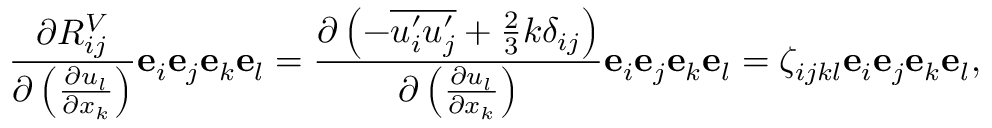<formula> <loc_0><loc_0><loc_500><loc_500>\frac { \partial R _ { i j } ^ { V } } { \partial \left ( \frac { \partial u _ { l } } { \partial x _ { k } } \right ) } e _ { i } e _ { j } e _ { k } e _ { l } = \frac { \partial \left ( - \overline { { u _ { i } ^ { \prime } u _ { j } ^ { \prime } } } + \frac { 2 } { 3 } k \delta _ { i j } \right ) } { \partial \left ( \frac { \partial u _ { l } } { \partial x _ { k } } \right ) } e _ { i } e _ { j } e _ { k } e _ { l } = \zeta _ { i j k l } e _ { i } e _ { j } e _ { k } e _ { l } ,</formula> 